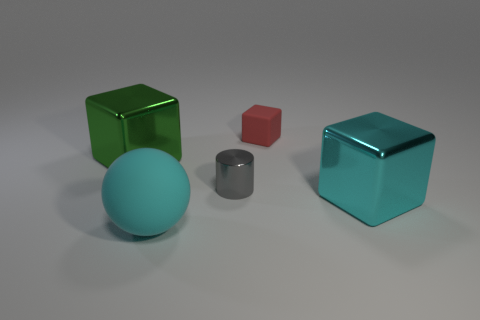Can you tell me about the textures of the objects? Certainly! The green and teal cubes have a reflective, slightly glossy surface suggesting a smooth, plastic-like texture. In contrast, the small gray cylinder and the red cube appear to have a matte finish, indicating a less reflective, possibly more tactile surface akin to stone or soft metal. 